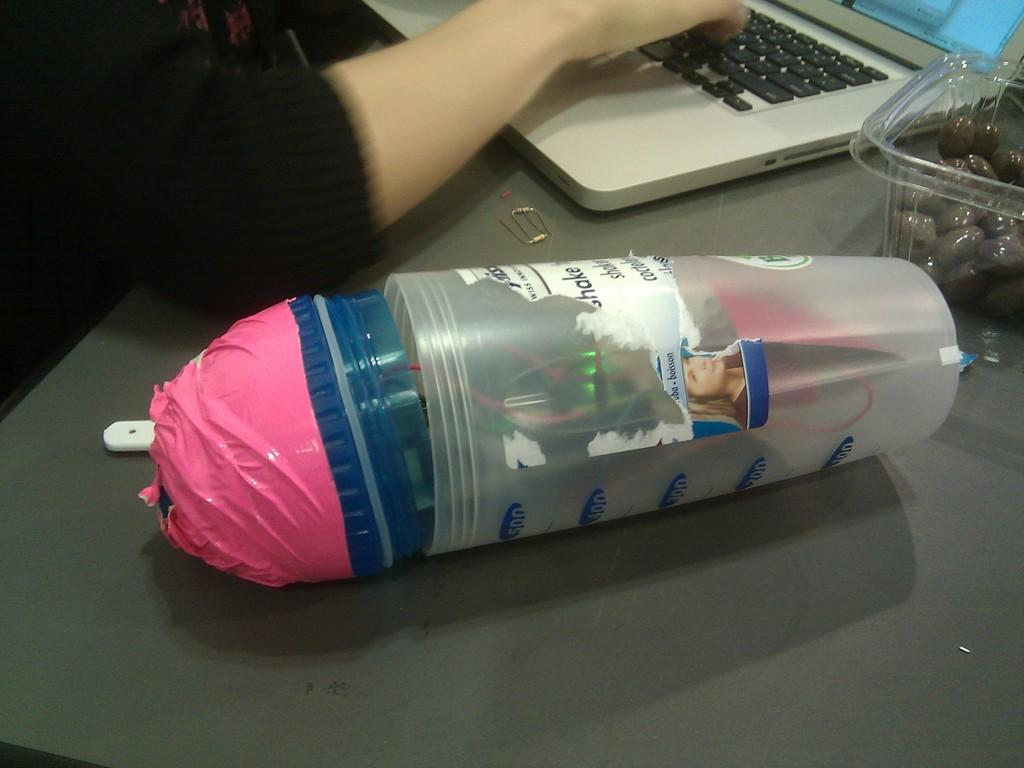<image>
Summarize the visual content of the image. A plastic container with measuring lines of 100 to 500 